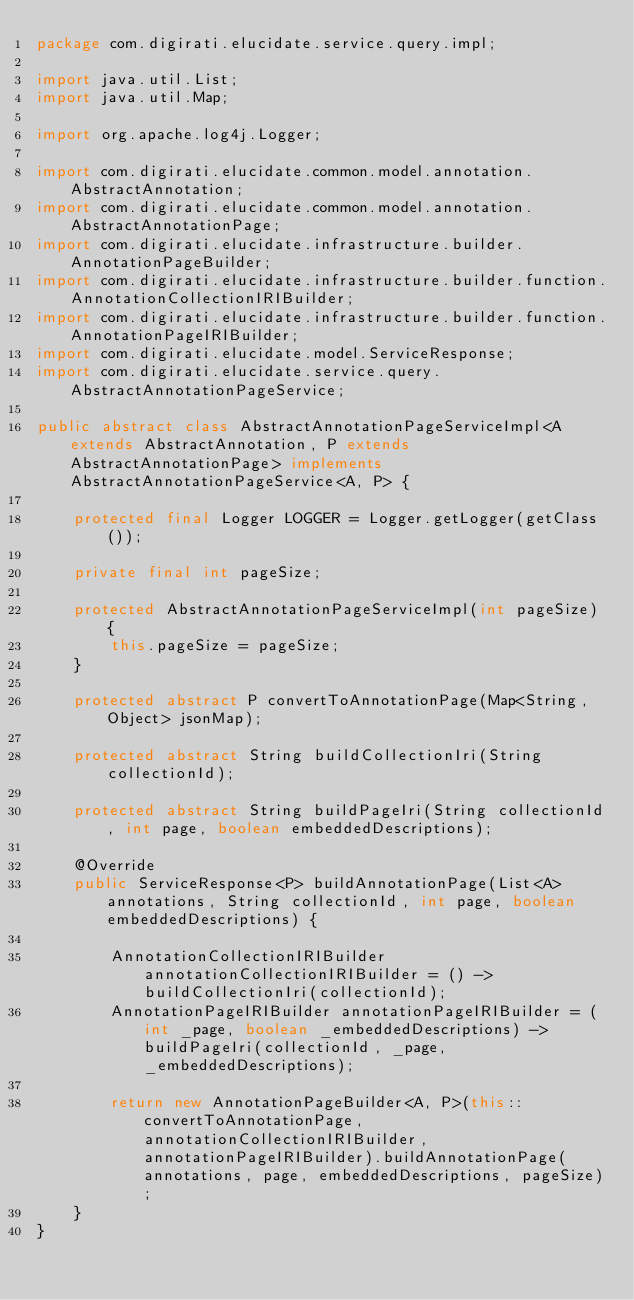<code> <loc_0><loc_0><loc_500><loc_500><_Java_>package com.digirati.elucidate.service.query.impl;

import java.util.List;
import java.util.Map;

import org.apache.log4j.Logger;

import com.digirati.elucidate.common.model.annotation.AbstractAnnotation;
import com.digirati.elucidate.common.model.annotation.AbstractAnnotationPage;
import com.digirati.elucidate.infrastructure.builder.AnnotationPageBuilder;
import com.digirati.elucidate.infrastructure.builder.function.AnnotationCollectionIRIBuilder;
import com.digirati.elucidate.infrastructure.builder.function.AnnotationPageIRIBuilder;
import com.digirati.elucidate.model.ServiceResponse;
import com.digirati.elucidate.service.query.AbstractAnnotationPageService;

public abstract class AbstractAnnotationPageServiceImpl<A extends AbstractAnnotation, P extends AbstractAnnotationPage> implements AbstractAnnotationPageService<A, P> {

    protected final Logger LOGGER = Logger.getLogger(getClass());

    private final int pageSize;

    protected AbstractAnnotationPageServiceImpl(int pageSize) {
        this.pageSize = pageSize;
    }

    protected abstract P convertToAnnotationPage(Map<String, Object> jsonMap);

    protected abstract String buildCollectionIri(String collectionId);

    protected abstract String buildPageIri(String collectionId, int page, boolean embeddedDescriptions);

    @Override
    public ServiceResponse<P> buildAnnotationPage(List<A> annotations, String collectionId, int page, boolean embeddedDescriptions) {

        AnnotationCollectionIRIBuilder annotationCollectionIRIBuilder = () -> buildCollectionIri(collectionId);
        AnnotationPageIRIBuilder annotationPageIRIBuilder = (int _page, boolean _embeddedDescriptions) -> buildPageIri(collectionId, _page, _embeddedDescriptions);

        return new AnnotationPageBuilder<A, P>(this::convertToAnnotationPage, annotationCollectionIRIBuilder, annotationPageIRIBuilder).buildAnnotationPage(annotations, page, embeddedDescriptions, pageSize);
    }
}
</code> 